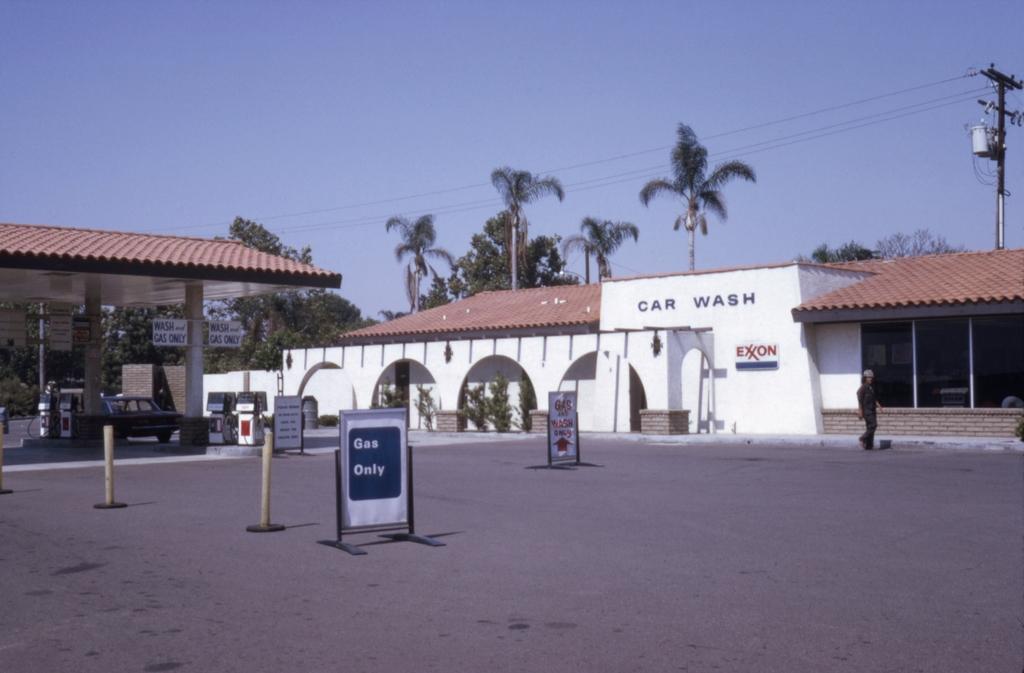Could you give a brief overview of what you see in this image? In this image we can see a building with text and a board, a person walking on the road, there are few boards and two rods on the road, there is a shed and few objects a car under the shed and there are trees, a current pole with wires and the sky in the background. 